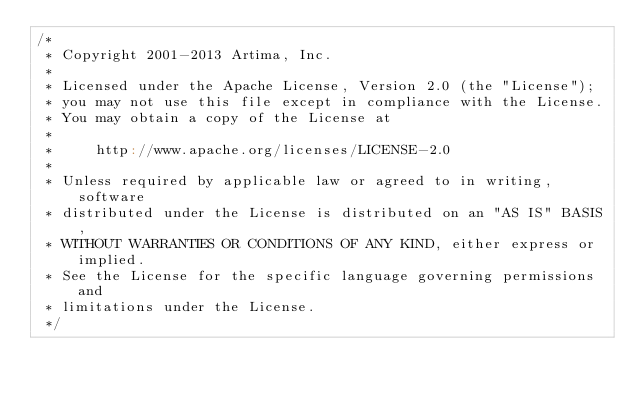Convert code to text. <code><loc_0><loc_0><loc_500><loc_500><_Scala_>/*
 * Copyright 2001-2013 Artima, Inc.
 *
 * Licensed under the Apache License, Version 2.0 (the "License");
 * you may not use this file except in compliance with the License.
 * You may obtain a copy of the License at
 *
 *     http://www.apache.org/licenses/LICENSE-2.0
 *
 * Unless required by applicable law or agreed to in writing, software
 * distributed under the License is distributed on an "AS IS" BASIS,
 * WITHOUT WARRANTIES OR CONDITIONS OF ANY KIND, either express or implied.
 * See the License for the specific language governing permissions and
 * limitations under the License.
 */</code> 